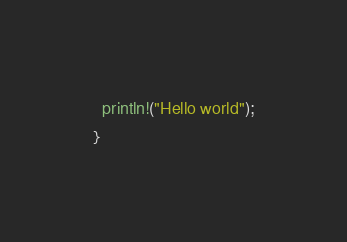<code> <loc_0><loc_0><loc_500><loc_500><_Rust_>  println!("Hello world");
}</code> 